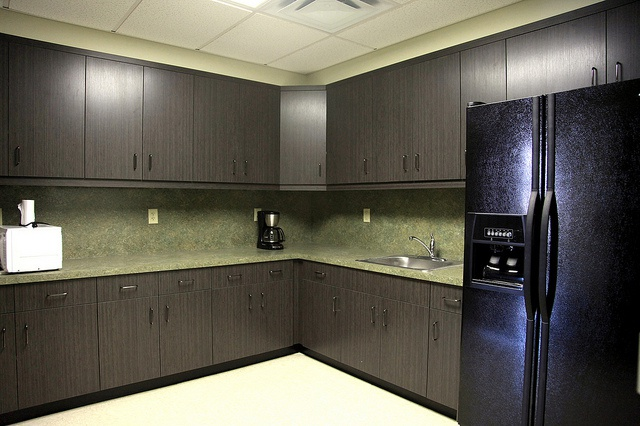Describe the objects in this image and their specific colors. I can see refrigerator in gray and black tones, microwave in gray, white, and darkgray tones, and sink in gray, darkgray, and ivory tones in this image. 